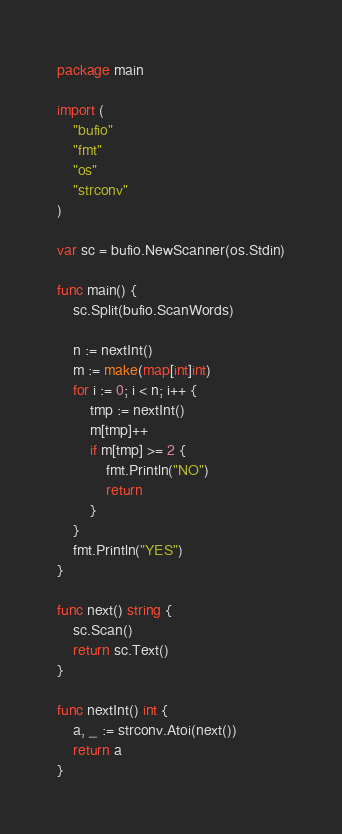<code> <loc_0><loc_0><loc_500><loc_500><_Go_>package main

import (
	"bufio"
	"fmt"
	"os"
	"strconv"
)

var sc = bufio.NewScanner(os.Stdin)

func main() {
	sc.Split(bufio.ScanWords)

	n := nextInt()
	m := make(map[int]int)
	for i := 0; i < n; i++ {
		tmp := nextInt()
		m[tmp]++
		if m[tmp] >= 2 {
			fmt.Println("NO")
			return
		}
	}
	fmt.Println("YES")
}

func next() string {
	sc.Scan()
	return sc.Text()
}

func nextInt() int {
	a, _ := strconv.Atoi(next())
	return a
}
</code> 